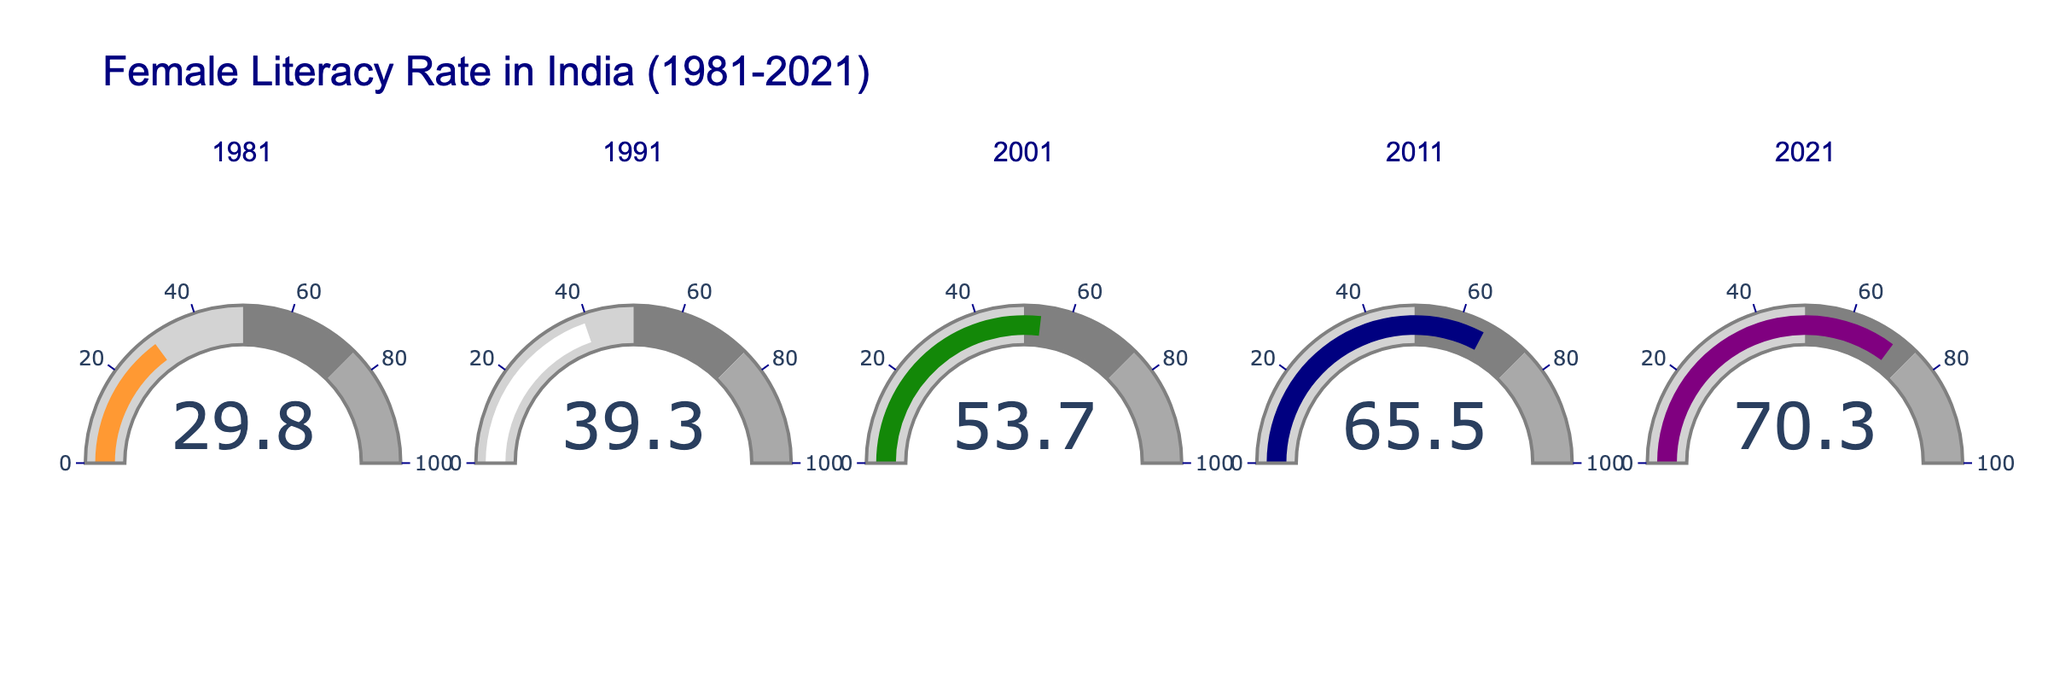What is the title of the figure? The title is generally located at the top of the figure. It provides a summary of the content presented in the figure.
Answer: Female Literacy Rate in India (1981-2021) How many years are shown in the figure? There is one gauge for each year shown in the figure. By counting the number of gauges, we can determine the number of years depicted.
Answer: 5 What are the years depicted in the figure? The subplot titles, which are aligned above each gauge, represent the years being visualized. Reading these titles provides the years.
Answer: 1981, 1991, 2001, 2011, 2021 What is the female literacy rate for the year 2001? Looking at the gauge labeled '2001,' we can see the numeric value displayed in the center of the gauge.
Answer: 53.7% Which year had the highest female literacy rate? By comparing the values in the center of each gauge, we identify the highest number among the years.
Answer: 2021 Which year had the lowest female literacy rate? By comparing the values in the center of each gauge, we identify the lowest number among the years.
Answer: 1981 What is the average female literacy rate across all the given years? To calculate the average, sum the literacy rates of all years and divide by the number of years. (29.8 + 39.3 + 53.7 + 65.5 + 70.3) / 5.
Answer: 51.72% What is the increase in female literacy rate from 1981 to 2021? The increase can be found by subtracting the 1981 literacy rate from the 2021 literacy rate. 70.3% - 29.8%.
Answer: 40.5% Which two consecutive years had the largest increase in literacy rate? By calculating the increase between each pair of consecutive years, we can determine which pair had the largest increase. 1991 to 2001: 53.7 - 39.3 = 14.4; 2001 to 2011: 65.5 - 53.7 = 11.8; 2011 to 2021: 70.3 - 65.5 = 4.8
Answer: 1991 to 2001 What color corresponds to the gauge for the year 2011? Each gauge is associated with a specific color. Observing the color of the gauge labeled '2011' reveals its color.
Answer: Dark blue 